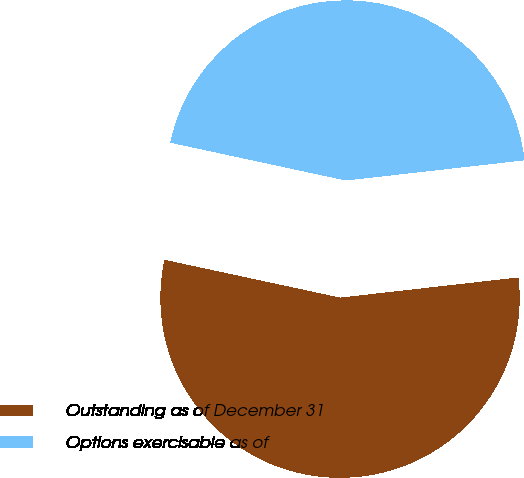Convert chart to OTSL. <chart><loc_0><loc_0><loc_500><loc_500><pie_chart><fcel>Outstanding as of December 31<fcel>Options exercisable as of<nl><fcel>55.17%<fcel>44.83%<nl></chart> 